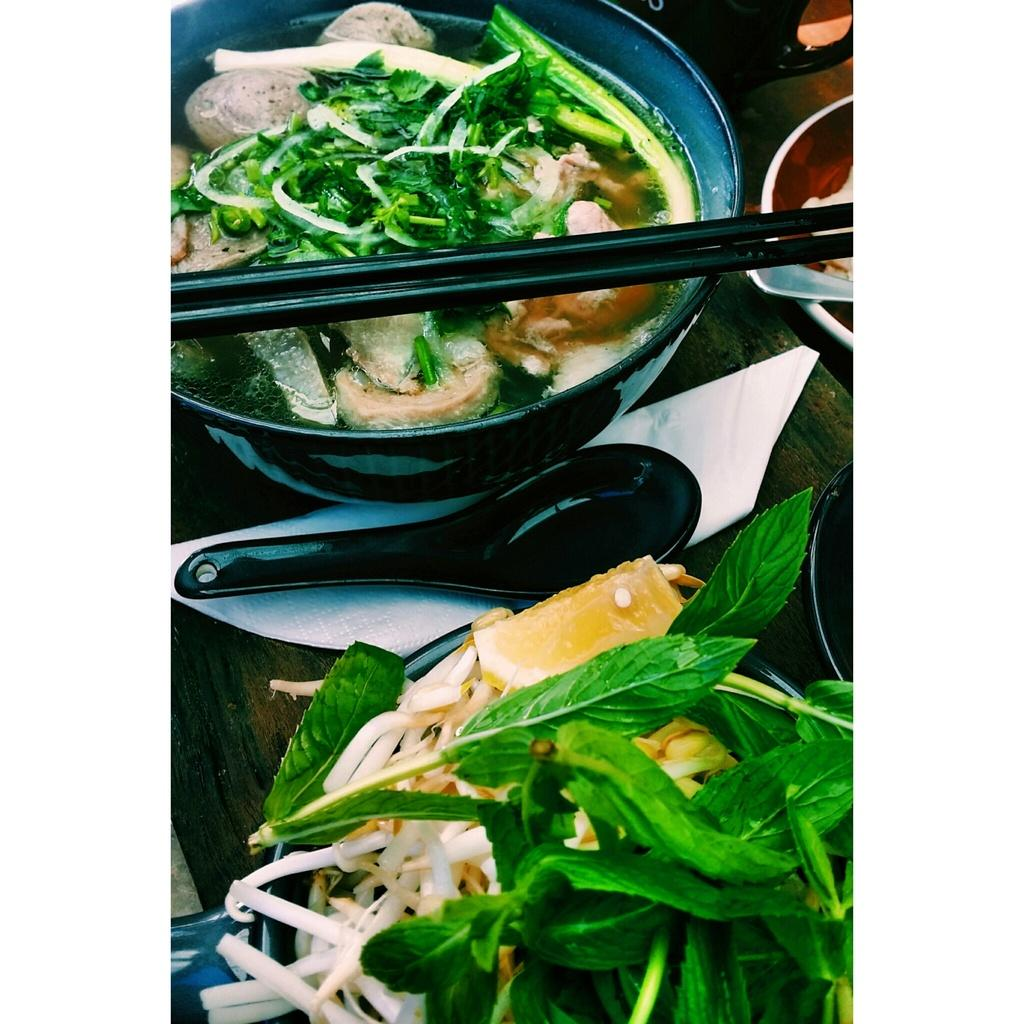What type of objects can be seen in the image? There are food items, a spoon, black color sticks, and balls in the image. What surface is visible in the image? The wooden surface is present in the image. What type of oil is being used to cook the food in the image? There is no indication of cooking or oil in the image; it only shows food items, a spoon, black color sticks, and balls on a wooden surface. 